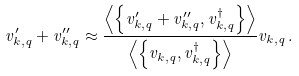Convert formula to latex. <formula><loc_0><loc_0><loc_500><loc_500>v _ { k , q } ^ { \prime } + v _ { k , q } ^ { \prime \prime } \approx \frac { \left \langle \left \{ v _ { k , q } ^ { \prime } + v _ { k , q } ^ { \prime \prime } , v _ { k , q } ^ { \dagger } \right \} \right \rangle } { \left \langle \left \{ v _ { k , q } , v _ { k , q } ^ { \dagger } \right \} \right \rangle } v _ { k , q } \, .</formula> 